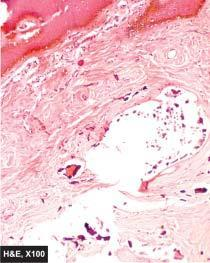does the subcutaneous tissue show masses or nodules of calcium salt surrounded by foreign body giant cells?
Answer the question using a single word or phrase. Yes 